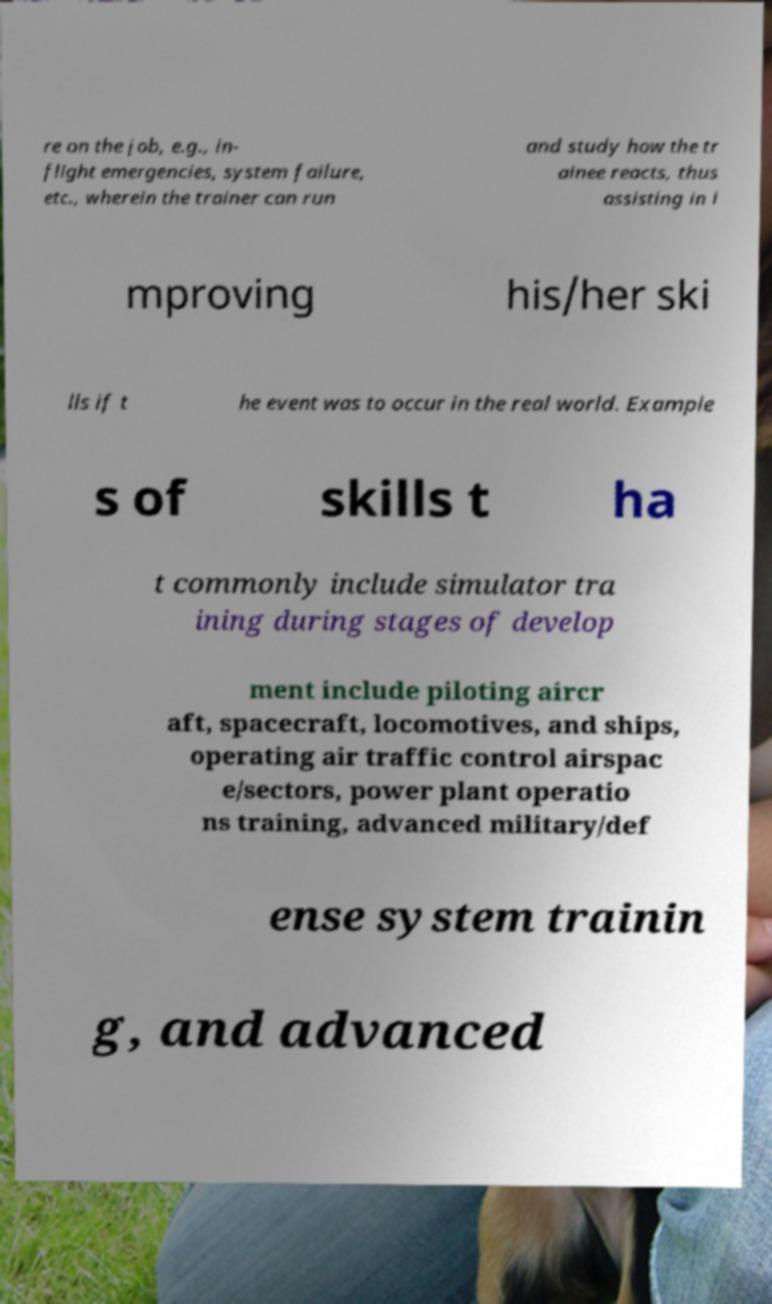Could you assist in decoding the text presented in this image and type it out clearly? re on the job, e.g., in- flight emergencies, system failure, etc., wherein the trainer can run and study how the tr ainee reacts, thus assisting in i mproving his/her ski lls if t he event was to occur in the real world. Example s of skills t ha t commonly include simulator tra ining during stages of develop ment include piloting aircr aft, spacecraft, locomotives, and ships, operating air traffic control airspac e/sectors, power plant operatio ns training, advanced military/def ense system trainin g, and advanced 